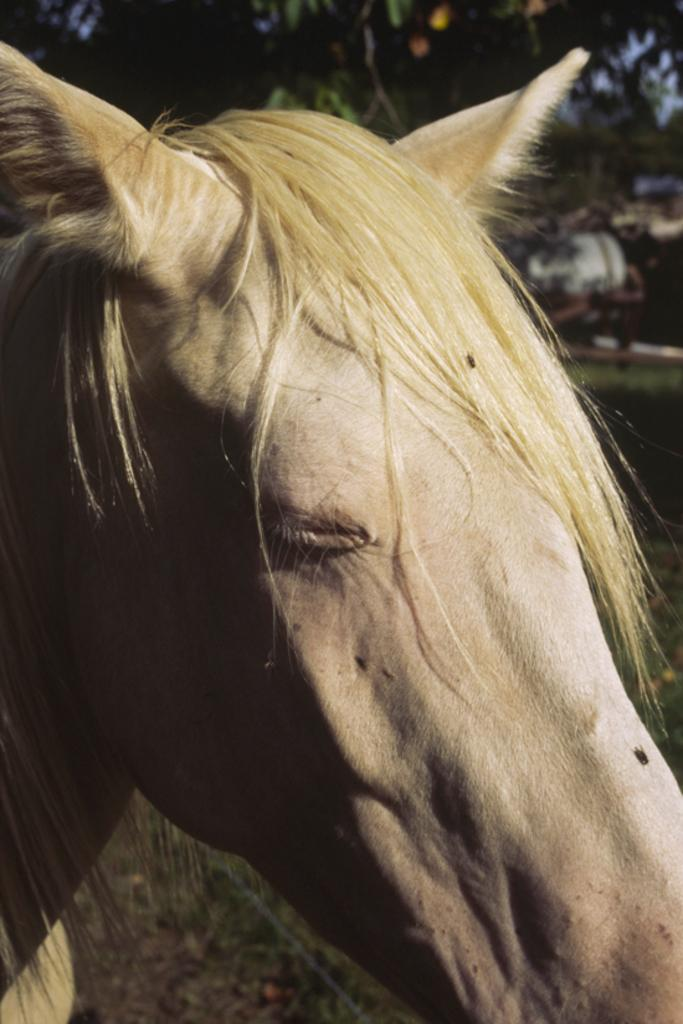What type of animal is in the image? There is an animal in the image, but its specific type cannot be determined from the provided facts. What color is the animal in the image? The animal is in cream color. What can be seen in the background of the image? There are trees and the sky visible in the background of the image. What is the color of the trees in the image? The trees are green. What is the color of the sky in the image? The sky is blue. What brand of toothpaste is the animal using in the image? There is no toothpaste present in the image, and therefore no such activity can be observed. Why is the animal crying in the image? There is no indication in the image that the animal is crying, and no reason for it to cry can be determined from the provided facts. 